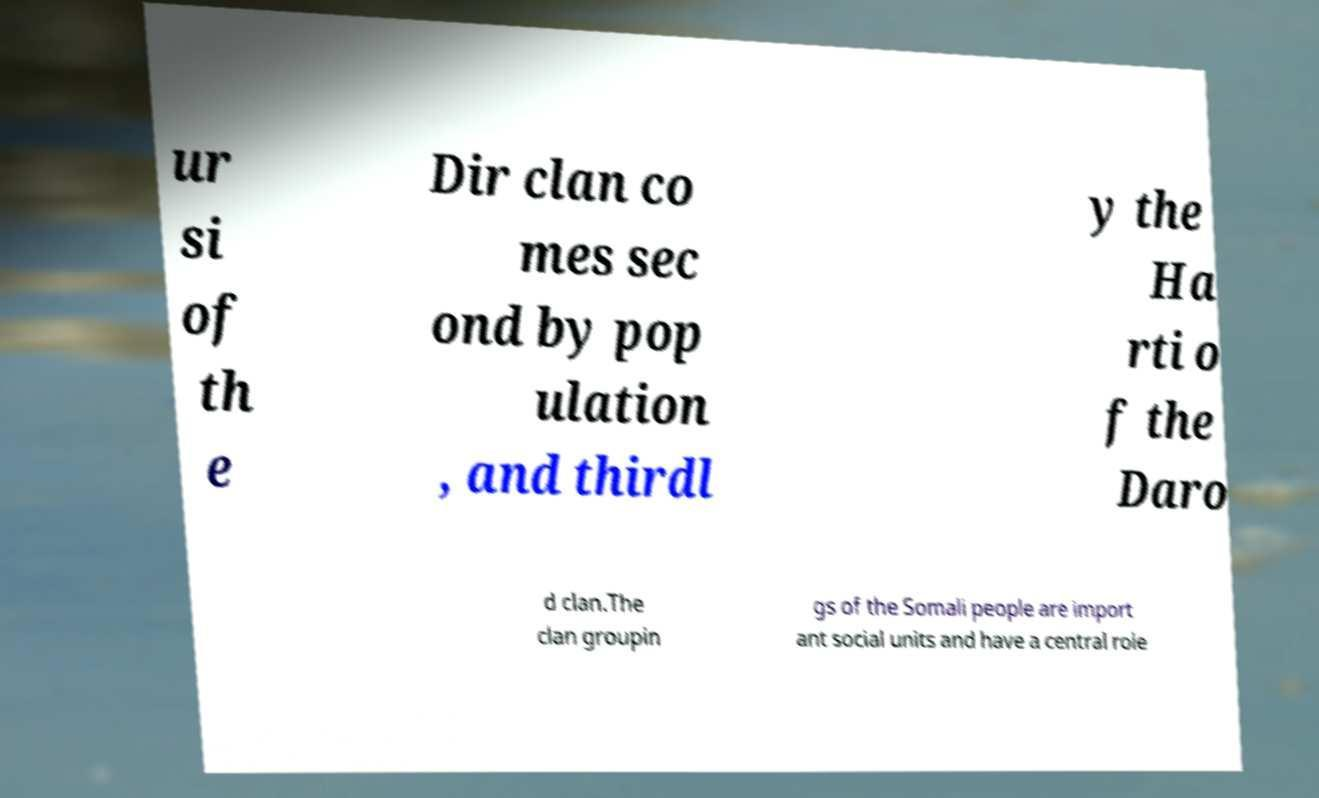Can you read and provide the text displayed in the image?This photo seems to have some interesting text. Can you extract and type it out for me? ur si of th e Dir clan co mes sec ond by pop ulation , and thirdl y the Ha rti o f the Daro d clan.The clan groupin gs of the Somali people are import ant social units and have a central role 